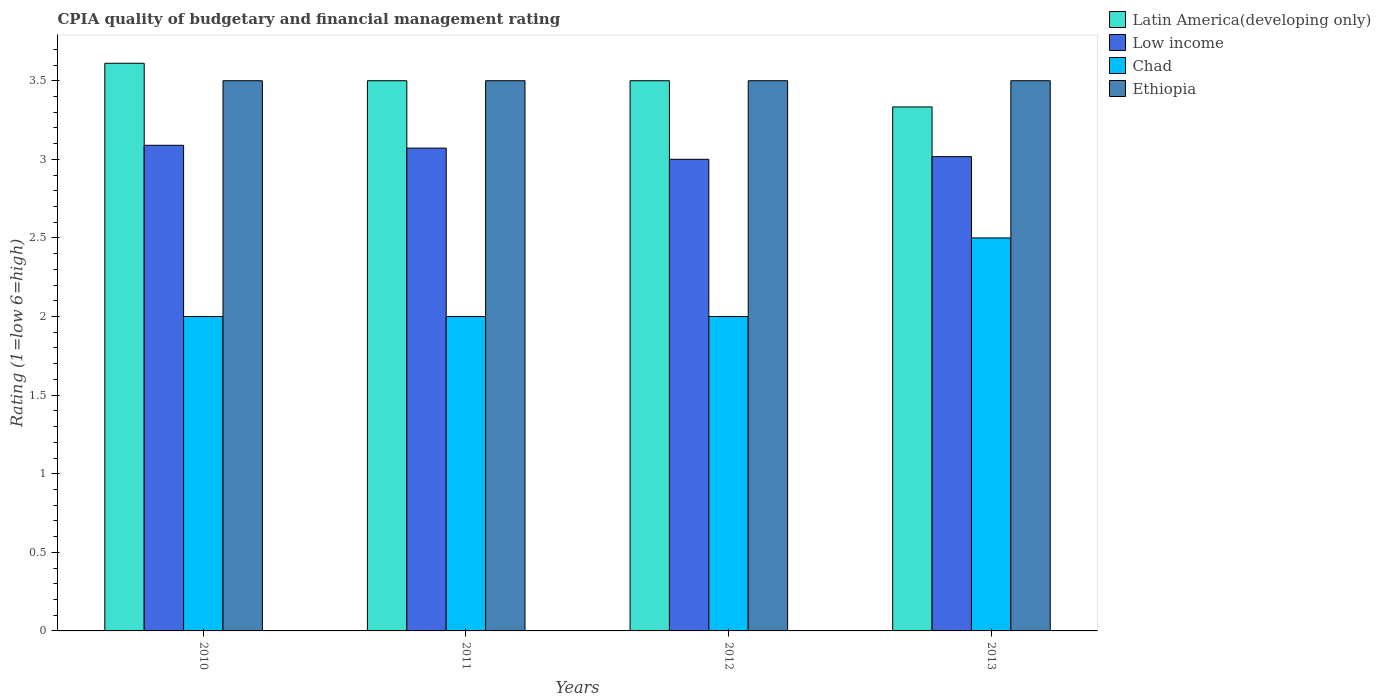How many different coloured bars are there?
Provide a short and direct response. 4. Are the number of bars on each tick of the X-axis equal?
Offer a very short reply. Yes. How many bars are there on the 1st tick from the left?
Make the answer very short. 4. What is the label of the 1st group of bars from the left?
Your answer should be compact. 2010. What is the CPIA rating in Ethiopia in 2012?
Keep it short and to the point. 3.5. Across all years, what is the maximum CPIA rating in Latin America(developing only)?
Make the answer very short. 3.61. What is the total CPIA rating in Chad in the graph?
Make the answer very short. 8.5. What is the difference between the CPIA rating in Latin America(developing only) in 2012 and that in 2013?
Provide a short and direct response. 0.17. What is the difference between the CPIA rating in Chad in 2010 and the CPIA rating in Low income in 2013?
Keep it short and to the point. -1.02. What is the average CPIA rating in Latin America(developing only) per year?
Provide a succinct answer. 3.49. In the year 2011, what is the difference between the CPIA rating in Low income and CPIA rating in Chad?
Offer a terse response. 1.07. In how many years, is the CPIA rating in Ethiopia greater than 3.6?
Give a very brief answer. 0. What is the ratio of the CPIA rating in Latin America(developing only) in 2010 to that in 2011?
Your answer should be very brief. 1.03. In how many years, is the CPIA rating in Latin America(developing only) greater than the average CPIA rating in Latin America(developing only) taken over all years?
Your answer should be very brief. 3. What does the 1st bar from the left in 2010 represents?
Make the answer very short. Latin America(developing only). What does the 1st bar from the right in 2013 represents?
Provide a succinct answer. Ethiopia. How many bars are there?
Your answer should be compact. 16. Are all the bars in the graph horizontal?
Keep it short and to the point. No. How many years are there in the graph?
Provide a succinct answer. 4. Are the values on the major ticks of Y-axis written in scientific E-notation?
Your answer should be very brief. No. Where does the legend appear in the graph?
Make the answer very short. Top right. How many legend labels are there?
Give a very brief answer. 4. How are the legend labels stacked?
Your answer should be compact. Vertical. What is the title of the graph?
Your answer should be compact. CPIA quality of budgetary and financial management rating. Does "Ethiopia" appear as one of the legend labels in the graph?
Your response must be concise. Yes. What is the label or title of the Y-axis?
Give a very brief answer. Rating (1=low 6=high). What is the Rating (1=low 6=high) of Latin America(developing only) in 2010?
Provide a short and direct response. 3.61. What is the Rating (1=low 6=high) of Low income in 2010?
Provide a succinct answer. 3.09. What is the Rating (1=low 6=high) of Ethiopia in 2010?
Your answer should be very brief. 3.5. What is the Rating (1=low 6=high) of Latin America(developing only) in 2011?
Keep it short and to the point. 3.5. What is the Rating (1=low 6=high) in Low income in 2011?
Make the answer very short. 3.07. What is the Rating (1=low 6=high) of Chad in 2011?
Ensure brevity in your answer.  2. What is the Rating (1=low 6=high) of Chad in 2012?
Offer a very short reply. 2. What is the Rating (1=low 6=high) of Latin America(developing only) in 2013?
Your answer should be compact. 3.33. What is the Rating (1=low 6=high) in Low income in 2013?
Make the answer very short. 3.02. What is the Rating (1=low 6=high) in Chad in 2013?
Provide a short and direct response. 2.5. Across all years, what is the maximum Rating (1=low 6=high) in Latin America(developing only)?
Ensure brevity in your answer.  3.61. Across all years, what is the maximum Rating (1=low 6=high) in Low income?
Provide a succinct answer. 3.09. Across all years, what is the maximum Rating (1=low 6=high) in Chad?
Offer a very short reply. 2.5. Across all years, what is the minimum Rating (1=low 6=high) of Latin America(developing only)?
Ensure brevity in your answer.  3.33. Across all years, what is the minimum Rating (1=low 6=high) of Low income?
Provide a succinct answer. 3. What is the total Rating (1=low 6=high) of Latin America(developing only) in the graph?
Keep it short and to the point. 13.94. What is the total Rating (1=low 6=high) in Low income in the graph?
Make the answer very short. 12.18. What is the difference between the Rating (1=low 6=high) of Latin America(developing only) in 2010 and that in 2011?
Ensure brevity in your answer.  0.11. What is the difference between the Rating (1=low 6=high) in Low income in 2010 and that in 2011?
Your answer should be very brief. 0.02. What is the difference between the Rating (1=low 6=high) of Low income in 2010 and that in 2012?
Make the answer very short. 0.09. What is the difference between the Rating (1=low 6=high) in Chad in 2010 and that in 2012?
Make the answer very short. 0. What is the difference between the Rating (1=low 6=high) in Latin America(developing only) in 2010 and that in 2013?
Your answer should be compact. 0.28. What is the difference between the Rating (1=low 6=high) of Low income in 2010 and that in 2013?
Provide a succinct answer. 0.07. What is the difference between the Rating (1=low 6=high) in Ethiopia in 2010 and that in 2013?
Give a very brief answer. 0. What is the difference between the Rating (1=low 6=high) in Low income in 2011 and that in 2012?
Your answer should be very brief. 0.07. What is the difference between the Rating (1=low 6=high) in Low income in 2011 and that in 2013?
Provide a succinct answer. 0.05. What is the difference between the Rating (1=low 6=high) of Chad in 2011 and that in 2013?
Offer a terse response. -0.5. What is the difference between the Rating (1=low 6=high) in Low income in 2012 and that in 2013?
Give a very brief answer. -0.02. What is the difference between the Rating (1=low 6=high) in Ethiopia in 2012 and that in 2013?
Make the answer very short. 0. What is the difference between the Rating (1=low 6=high) of Latin America(developing only) in 2010 and the Rating (1=low 6=high) of Low income in 2011?
Offer a terse response. 0.54. What is the difference between the Rating (1=low 6=high) of Latin America(developing only) in 2010 and the Rating (1=low 6=high) of Chad in 2011?
Keep it short and to the point. 1.61. What is the difference between the Rating (1=low 6=high) of Latin America(developing only) in 2010 and the Rating (1=low 6=high) of Ethiopia in 2011?
Keep it short and to the point. 0.11. What is the difference between the Rating (1=low 6=high) in Low income in 2010 and the Rating (1=low 6=high) in Chad in 2011?
Make the answer very short. 1.09. What is the difference between the Rating (1=low 6=high) of Low income in 2010 and the Rating (1=low 6=high) of Ethiopia in 2011?
Keep it short and to the point. -0.41. What is the difference between the Rating (1=low 6=high) in Chad in 2010 and the Rating (1=low 6=high) in Ethiopia in 2011?
Your answer should be compact. -1.5. What is the difference between the Rating (1=low 6=high) in Latin America(developing only) in 2010 and the Rating (1=low 6=high) in Low income in 2012?
Provide a short and direct response. 0.61. What is the difference between the Rating (1=low 6=high) of Latin America(developing only) in 2010 and the Rating (1=low 6=high) of Chad in 2012?
Your response must be concise. 1.61. What is the difference between the Rating (1=low 6=high) of Low income in 2010 and the Rating (1=low 6=high) of Chad in 2012?
Ensure brevity in your answer.  1.09. What is the difference between the Rating (1=low 6=high) of Low income in 2010 and the Rating (1=low 6=high) of Ethiopia in 2012?
Offer a very short reply. -0.41. What is the difference between the Rating (1=low 6=high) of Chad in 2010 and the Rating (1=low 6=high) of Ethiopia in 2012?
Make the answer very short. -1.5. What is the difference between the Rating (1=low 6=high) in Latin America(developing only) in 2010 and the Rating (1=low 6=high) in Low income in 2013?
Keep it short and to the point. 0.59. What is the difference between the Rating (1=low 6=high) in Latin America(developing only) in 2010 and the Rating (1=low 6=high) in Chad in 2013?
Provide a succinct answer. 1.11. What is the difference between the Rating (1=low 6=high) of Latin America(developing only) in 2010 and the Rating (1=low 6=high) of Ethiopia in 2013?
Your answer should be compact. 0.11. What is the difference between the Rating (1=low 6=high) of Low income in 2010 and the Rating (1=low 6=high) of Chad in 2013?
Make the answer very short. 0.59. What is the difference between the Rating (1=low 6=high) of Low income in 2010 and the Rating (1=low 6=high) of Ethiopia in 2013?
Your answer should be compact. -0.41. What is the difference between the Rating (1=low 6=high) of Latin America(developing only) in 2011 and the Rating (1=low 6=high) of Chad in 2012?
Ensure brevity in your answer.  1.5. What is the difference between the Rating (1=low 6=high) in Latin America(developing only) in 2011 and the Rating (1=low 6=high) in Ethiopia in 2012?
Keep it short and to the point. 0. What is the difference between the Rating (1=low 6=high) in Low income in 2011 and the Rating (1=low 6=high) in Chad in 2012?
Make the answer very short. 1.07. What is the difference between the Rating (1=low 6=high) in Low income in 2011 and the Rating (1=low 6=high) in Ethiopia in 2012?
Your response must be concise. -0.43. What is the difference between the Rating (1=low 6=high) in Latin America(developing only) in 2011 and the Rating (1=low 6=high) in Low income in 2013?
Make the answer very short. 0.48. What is the difference between the Rating (1=low 6=high) of Latin America(developing only) in 2011 and the Rating (1=low 6=high) of Chad in 2013?
Provide a succinct answer. 1. What is the difference between the Rating (1=low 6=high) of Low income in 2011 and the Rating (1=low 6=high) of Chad in 2013?
Ensure brevity in your answer.  0.57. What is the difference between the Rating (1=low 6=high) in Low income in 2011 and the Rating (1=low 6=high) in Ethiopia in 2013?
Provide a short and direct response. -0.43. What is the difference between the Rating (1=low 6=high) in Chad in 2011 and the Rating (1=low 6=high) in Ethiopia in 2013?
Make the answer very short. -1.5. What is the difference between the Rating (1=low 6=high) of Latin America(developing only) in 2012 and the Rating (1=low 6=high) of Low income in 2013?
Your answer should be very brief. 0.48. What is the difference between the Rating (1=low 6=high) of Latin America(developing only) in 2012 and the Rating (1=low 6=high) of Ethiopia in 2013?
Provide a succinct answer. 0. What is the difference between the Rating (1=low 6=high) of Low income in 2012 and the Rating (1=low 6=high) of Ethiopia in 2013?
Provide a short and direct response. -0.5. What is the difference between the Rating (1=low 6=high) in Chad in 2012 and the Rating (1=low 6=high) in Ethiopia in 2013?
Provide a short and direct response. -1.5. What is the average Rating (1=low 6=high) in Latin America(developing only) per year?
Provide a short and direct response. 3.49. What is the average Rating (1=low 6=high) in Low income per year?
Your response must be concise. 3.04. What is the average Rating (1=low 6=high) in Chad per year?
Offer a very short reply. 2.12. In the year 2010, what is the difference between the Rating (1=low 6=high) of Latin America(developing only) and Rating (1=low 6=high) of Low income?
Make the answer very short. 0.52. In the year 2010, what is the difference between the Rating (1=low 6=high) in Latin America(developing only) and Rating (1=low 6=high) in Chad?
Make the answer very short. 1.61. In the year 2010, what is the difference between the Rating (1=low 6=high) of Latin America(developing only) and Rating (1=low 6=high) of Ethiopia?
Provide a short and direct response. 0.11. In the year 2010, what is the difference between the Rating (1=low 6=high) of Low income and Rating (1=low 6=high) of Chad?
Offer a very short reply. 1.09. In the year 2010, what is the difference between the Rating (1=low 6=high) of Low income and Rating (1=low 6=high) of Ethiopia?
Keep it short and to the point. -0.41. In the year 2011, what is the difference between the Rating (1=low 6=high) in Latin America(developing only) and Rating (1=low 6=high) in Low income?
Your answer should be very brief. 0.43. In the year 2011, what is the difference between the Rating (1=low 6=high) in Low income and Rating (1=low 6=high) in Chad?
Ensure brevity in your answer.  1.07. In the year 2011, what is the difference between the Rating (1=low 6=high) of Low income and Rating (1=low 6=high) of Ethiopia?
Ensure brevity in your answer.  -0.43. In the year 2011, what is the difference between the Rating (1=low 6=high) in Chad and Rating (1=low 6=high) in Ethiopia?
Your response must be concise. -1.5. In the year 2012, what is the difference between the Rating (1=low 6=high) of Latin America(developing only) and Rating (1=low 6=high) of Chad?
Make the answer very short. 1.5. In the year 2013, what is the difference between the Rating (1=low 6=high) of Latin America(developing only) and Rating (1=low 6=high) of Low income?
Give a very brief answer. 0.32. In the year 2013, what is the difference between the Rating (1=low 6=high) of Latin America(developing only) and Rating (1=low 6=high) of Chad?
Ensure brevity in your answer.  0.83. In the year 2013, what is the difference between the Rating (1=low 6=high) of Low income and Rating (1=low 6=high) of Chad?
Your answer should be very brief. 0.52. In the year 2013, what is the difference between the Rating (1=low 6=high) of Low income and Rating (1=low 6=high) of Ethiopia?
Give a very brief answer. -0.48. In the year 2013, what is the difference between the Rating (1=low 6=high) in Chad and Rating (1=low 6=high) in Ethiopia?
Offer a very short reply. -1. What is the ratio of the Rating (1=low 6=high) in Latin America(developing only) in 2010 to that in 2011?
Keep it short and to the point. 1.03. What is the ratio of the Rating (1=low 6=high) of Chad in 2010 to that in 2011?
Provide a succinct answer. 1. What is the ratio of the Rating (1=low 6=high) of Ethiopia in 2010 to that in 2011?
Provide a short and direct response. 1. What is the ratio of the Rating (1=low 6=high) in Latin America(developing only) in 2010 to that in 2012?
Your answer should be compact. 1.03. What is the ratio of the Rating (1=low 6=high) of Low income in 2010 to that in 2012?
Your answer should be very brief. 1.03. What is the ratio of the Rating (1=low 6=high) of Chad in 2010 to that in 2012?
Your answer should be very brief. 1. What is the ratio of the Rating (1=low 6=high) in Ethiopia in 2010 to that in 2012?
Provide a succinct answer. 1. What is the ratio of the Rating (1=low 6=high) of Low income in 2010 to that in 2013?
Keep it short and to the point. 1.02. What is the ratio of the Rating (1=low 6=high) in Chad in 2010 to that in 2013?
Keep it short and to the point. 0.8. What is the ratio of the Rating (1=low 6=high) of Ethiopia in 2010 to that in 2013?
Offer a very short reply. 1. What is the ratio of the Rating (1=low 6=high) of Low income in 2011 to that in 2012?
Offer a very short reply. 1.02. What is the ratio of the Rating (1=low 6=high) in Chad in 2011 to that in 2012?
Give a very brief answer. 1. What is the ratio of the Rating (1=low 6=high) in Ethiopia in 2011 to that in 2012?
Keep it short and to the point. 1. What is the ratio of the Rating (1=low 6=high) in Chad in 2011 to that in 2013?
Your response must be concise. 0.8. What is the ratio of the Rating (1=low 6=high) of Ethiopia in 2011 to that in 2013?
Provide a succinct answer. 1. What is the ratio of the Rating (1=low 6=high) in Latin America(developing only) in 2012 to that in 2013?
Provide a short and direct response. 1.05. What is the ratio of the Rating (1=low 6=high) in Low income in 2012 to that in 2013?
Offer a very short reply. 0.99. What is the ratio of the Rating (1=low 6=high) in Ethiopia in 2012 to that in 2013?
Your answer should be very brief. 1. What is the difference between the highest and the second highest Rating (1=low 6=high) in Latin America(developing only)?
Provide a short and direct response. 0.11. What is the difference between the highest and the second highest Rating (1=low 6=high) of Low income?
Offer a very short reply. 0.02. What is the difference between the highest and the second highest Rating (1=low 6=high) of Ethiopia?
Your response must be concise. 0. What is the difference between the highest and the lowest Rating (1=low 6=high) in Latin America(developing only)?
Your answer should be very brief. 0.28. What is the difference between the highest and the lowest Rating (1=low 6=high) of Low income?
Ensure brevity in your answer.  0.09. 